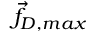Convert formula to latex. <formula><loc_0><loc_0><loc_500><loc_500>\vec { f } _ { D , \max }</formula> 